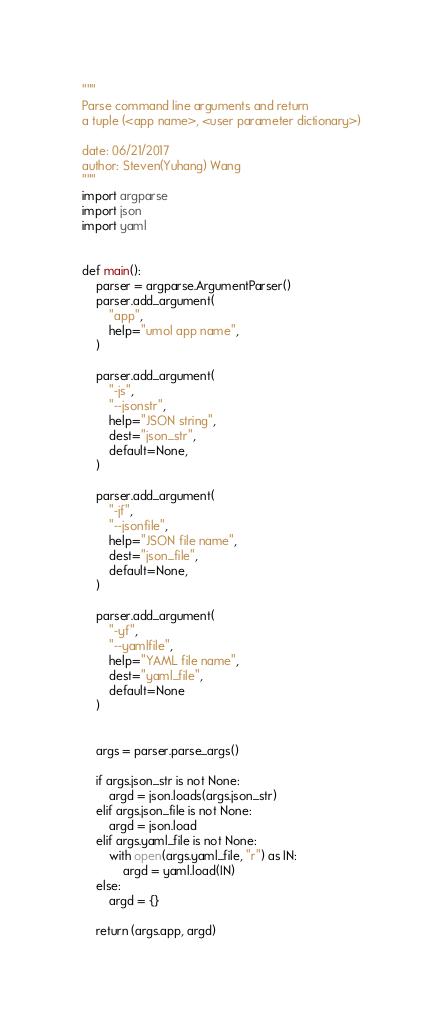Convert code to text. <code><loc_0><loc_0><loc_500><loc_500><_Python_>"""
Parse command line arguments and return
a tuple (<app name>, <user parameter dictionary>)

date: 06/21/2017
author: Steven(Yuhang) Wang
"""
import argparse
import json
import yaml


def main():
    parser = argparse.ArgumentParser()
    parser.add_argument(
        "app",
        help="umol app name",
    )

    parser.add_argument(
        "-js",
        "--jsonstr",
        help="JSON string",
        dest="json_str",
        default=None,
    )

    parser.add_argument(
        "-jf",
        "--jsonfile",
        help="JSON file name",
        dest="json_file",
        default=None,
    )

    parser.add_argument(
        "-yf",
        "--yamlfile",
        help="YAML file name",
        dest="yaml_file",
        default=None
    )


    args = parser.parse_args()

    if args.json_str is not None:
        argd = json.loads(args.json_str)
    elif args.json_file is not None:
        argd = json.load
    elif args.yaml_file is not None:
        with open(args.yaml_file, "r") as IN:
            argd = yaml.load(IN)
    else:
        argd = {}

    return (args.app, argd)
</code> 